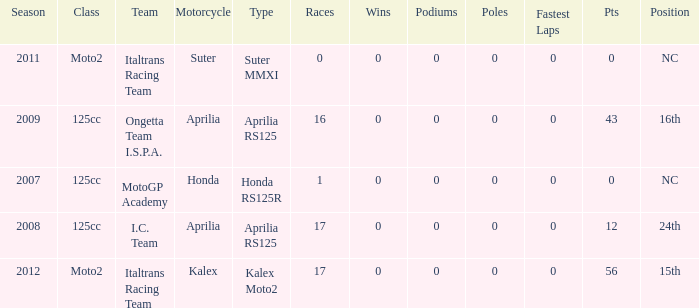What's the name of the team who had a Honda motorcycle? MotoGP Academy. 